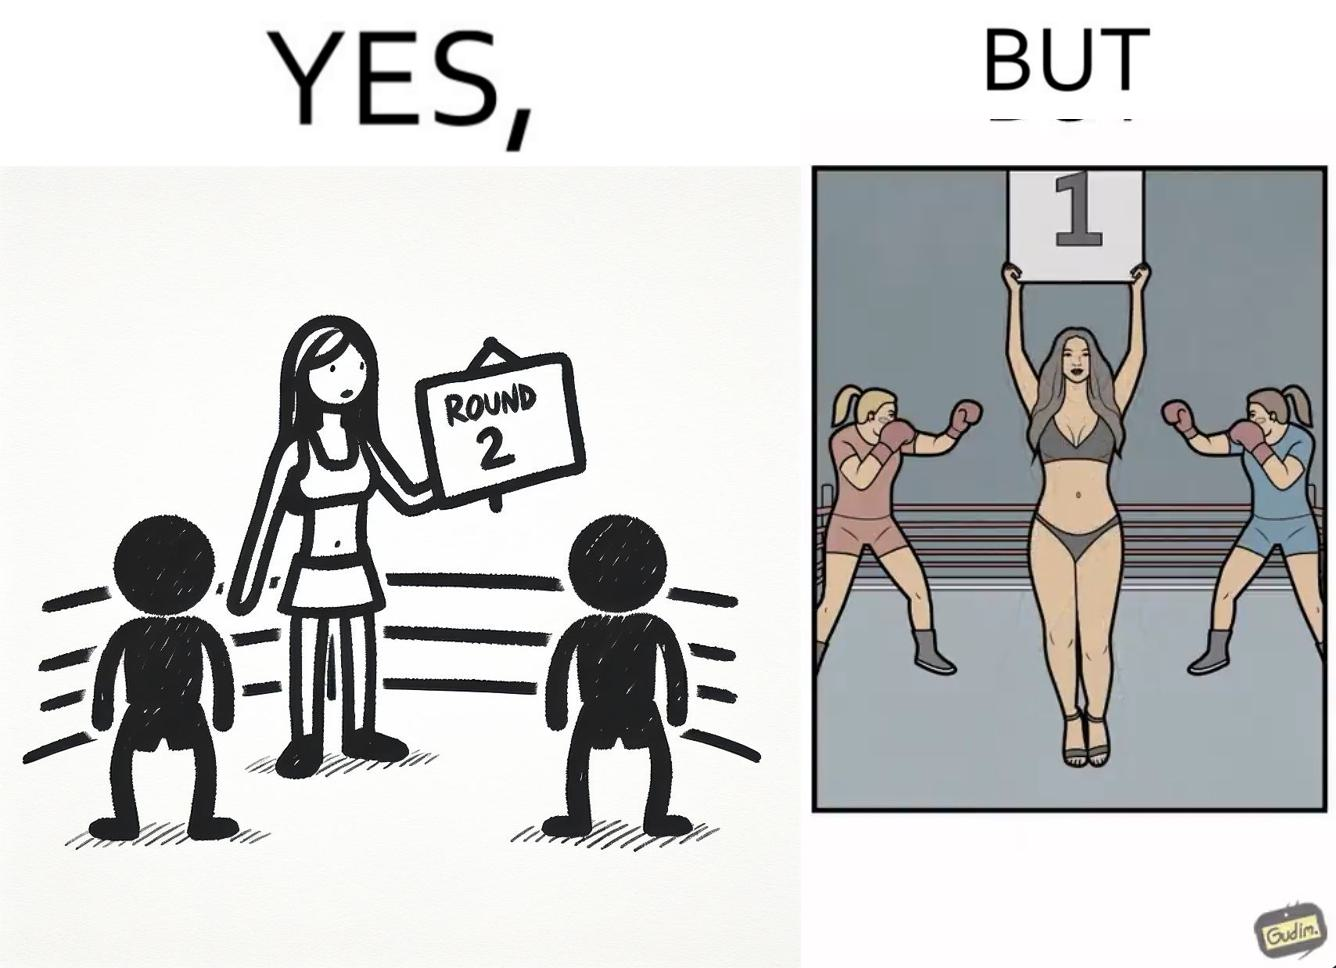Does this image contain satire or humor? Yes, this image is satirical. 